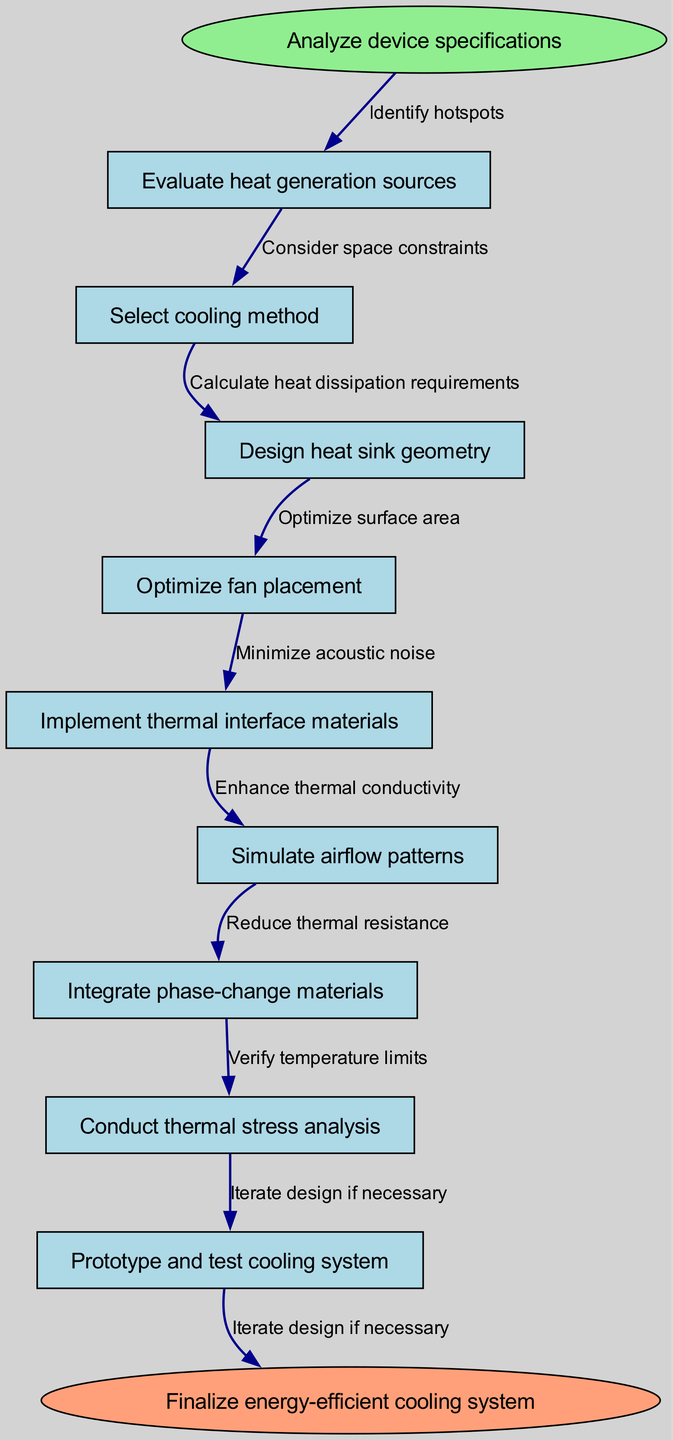What is the first step in the cooling system design process? The first step is indicated by the start node, which states "Analyze device specifications". This node clearly marks the beginning of the process flow in the diagram.
Answer: Analyze device specifications How many nodes are present in the diagram? To determine the total number of nodes, we count all the specified nodes including the start and end nodes, which totals 10 nodes in the flowchart.
Answer: 10 What method follows selecting the cooling method? In the flow of the diagram, after "Select cooling method", the next step is "Design heat sink geometry". This can be traced by following the arrows that connect each action in sequence.
Answer: Design heat sink geometry Which node has the last action before finalizing the system? The last action before reaching the final node is "Prototype and test cooling system". This is the second to last node in the directed graph, leading directly to the end.
Answer: Prototype and test cooling system What is the relationship between 'Design heat sink geometry' and 'Optimize fan placement'? According to the diagram, 'Design heat sink geometry' flows directly into 'Optimize fan placement' with an edge connecting these two nodes labeled "Calculate heat dissipation requirements", indicating a sequential relationship.
Answer: Calculate heat dissipation requirements How many edges connect to the end node? The end node "Finalize energy-efficient cooling system" has exactly one edge connecting from the previous step "Prototype and test cooling system", which marks the completion of the process.
Answer: 1 Which design step requires minimizing acoustic noise? In the flow, "Optimize fan placement" is the node that requires minimizing acoustic noise, as indicated by the edge labeling between these two actions.
Answer: Optimize fan placement How does heat generation affect the cooling system design? The first step in the flow diagram "Evaluate heat generation sources" directly takes into consideration how heat generation plays a role in selecting appropriate cooling methods and subsequent designs. This emphasizes the importance of identifying heat sources early in the design process.
Answer: Evaluate heat generation sources What action comes after integrating phase-change materials? The next action after "Integrate phase-change materials" is "Conduct thermal stress analysis". Following the diagram's flow, this step assesses the system's thermal integrity post-integration.
Answer: Conduct thermal stress analysis 